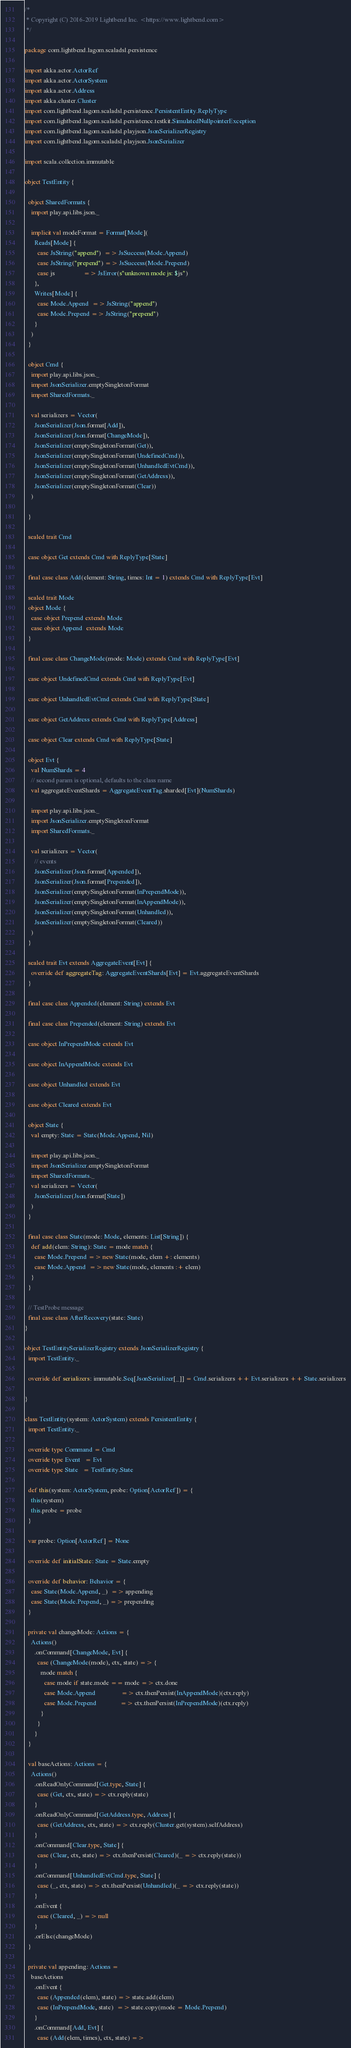Convert code to text. <code><loc_0><loc_0><loc_500><loc_500><_Scala_>/*
 * Copyright (C) 2016-2019 Lightbend Inc. <https://www.lightbend.com>
 */

package com.lightbend.lagom.scaladsl.persistence

import akka.actor.ActorRef
import akka.actor.ActorSystem
import akka.actor.Address
import akka.cluster.Cluster
import com.lightbend.lagom.scaladsl.persistence.PersistentEntity.ReplyType
import com.lightbend.lagom.scaladsl.persistence.testkit.SimulatedNullpointerException
import com.lightbend.lagom.scaladsl.playjson.JsonSerializerRegistry
import com.lightbend.lagom.scaladsl.playjson.JsonSerializer

import scala.collection.immutable

object TestEntity {

  object SharedFormats {
    import play.api.libs.json._

    implicit val modeFormat = Format[Mode](
      Reads[Mode] {
        case JsString("append")  => JsSuccess(Mode.Append)
        case JsString("prepend") => JsSuccess(Mode.Prepend)
        case js                  => JsError(s"unknown mode js: $js")
      },
      Writes[Mode] {
        case Mode.Append  => JsString("append")
        case Mode.Prepend => JsString("prepend")
      }
    )
  }

  object Cmd {
    import play.api.libs.json._
    import JsonSerializer.emptySingletonFormat
    import SharedFormats._

    val serializers = Vector(
      JsonSerializer(Json.format[Add]),
      JsonSerializer(Json.format[ChangeMode]),
      JsonSerializer(emptySingletonFormat(Get)),
      JsonSerializer(emptySingletonFormat(UndefinedCmd)),
      JsonSerializer(emptySingletonFormat(UnhandledEvtCmd)),
      JsonSerializer(emptySingletonFormat(GetAddress)),
      JsonSerializer(emptySingletonFormat(Clear))
    )

  }

  sealed trait Cmd

  case object Get extends Cmd with ReplyType[State]

  final case class Add(element: String, times: Int = 1) extends Cmd with ReplyType[Evt]

  sealed trait Mode
  object Mode {
    case object Prepend extends Mode
    case object Append  extends Mode
  }

  final case class ChangeMode(mode: Mode) extends Cmd with ReplyType[Evt]

  case object UndefinedCmd extends Cmd with ReplyType[Evt]

  case object UnhandledEvtCmd extends Cmd with ReplyType[State]

  case object GetAddress extends Cmd with ReplyType[Address]

  case object Clear extends Cmd with ReplyType[State]

  object Evt {
    val NumShards = 4
    // second param is optional, defaults to the class name
    val aggregateEventShards = AggregateEventTag.sharded[Evt](NumShards)

    import play.api.libs.json._
    import JsonSerializer.emptySingletonFormat
    import SharedFormats._

    val serializers = Vector(
      // events
      JsonSerializer(Json.format[Appended]),
      JsonSerializer(Json.format[Prepended]),
      JsonSerializer(emptySingletonFormat(InPrependMode)),
      JsonSerializer(emptySingletonFormat(InAppendMode)),
      JsonSerializer(emptySingletonFormat(Unhandled)),
      JsonSerializer(emptySingletonFormat(Cleared))
    )
  }

  sealed trait Evt extends AggregateEvent[Evt] {
    override def aggregateTag: AggregateEventShards[Evt] = Evt.aggregateEventShards
  }

  final case class Appended(element: String) extends Evt

  final case class Prepended(element: String) extends Evt

  case object InPrependMode extends Evt

  case object InAppendMode extends Evt

  case object Unhandled extends Evt

  case object Cleared extends Evt

  object State {
    val empty: State = State(Mode.Append, Nil)

    import play.api.libs.json._
    import JsonSerializer.emptySingletonFormat
    import SharedFormats._
    val serializers = Vector(
      JsonSerializer(Json.format[State])
    )
  }

  final case class State(mode: Mode, elements: List[String]) {
    def add(elem: String): State = mode match {
      case Mode.Prepend => new State(mode, elem +: elements)
      case Mode.Append  => new State(mode, elements :+ elem)
    }
  }

  // TestProbe message
  final case class AfterRecovery(state: State)
}

object TestEntitySerializerRegistry extends JsonSerializerRegistry {
  import TestEntity._

  override def serializers: immutable.Seq[JsonSerializer[_]] = Cmd.serializers ++ Evt.serializers ++ State.serializers

}

class TestEntity(system: ActorSystem) extends PersistentEntity {
  import TestEntity._

  override type Command = Cmd
  override type Event   = Evt
  override type State   = TestEntity.State

  def this(system: ActorSystem, probe: Option[ActorRef]) = {
    this(system)
    this.probe = probe
  }

  var probe: Option[ActorRef] = None

  override def initialState: State = State.empty

  override def behavior: Behavior = {
    case State(Mode.Append, _)  => appending
    case State(Mode.Prepend, _) => prepending
  }

  private val changeMode: Actions = {
    Actions()
      .onCommand[ChangeMode, Evt] {
        case (ChangeMode(mode), ctx, state) => {
          mode match {
            case mode if state.mode == mode => ctx.done
            case Mode.Append                => ctx.thenPersist(InAppendMode)(ctx.reply)
            case Mode.Prepend               => ctx.thenPersist(InPrependMode)(ctx.reply)
          }
        }
      }
  }

  val baseActions: Actions = {
    Actions()
      .onReadOnlyCommand[Get.type, State] {
        case (Get, ctx, state) => ctx.reply(state)
      }
      .onReadOnlyCommand[GetAddress.type, Address] {
        case (GetAddress, ctx, state) => ctx.reply(Cluster.get(system).selfAddress)
      }
      .onCommand[Clear.type, State] {
        case (Clear, ctx, state) => ctx.thenPersist(Cleared)(_ => ctx.reply(state))
      }
      .onCommand[UnhandledEvtCmd.type, State] {
        case (_, ctx, state) => ctx.thenPersist(Unhandled)(_ => ctx.reply(state))
      }
      .onEvent {
        case (Cleared, _) => null
      }
      .orElse(changeMode)
  }

  private val appending: Actions =
    baseActions
      .onEvent {
        case (Appended(elem), state) => state.add(elem)
        case (InPrependMode, state)  => state.copy(mode = Mode.Prepend)
      }
      .onCommand[Add, Evt] {
        case (Add(elem, times), ctx, state) =></code> 